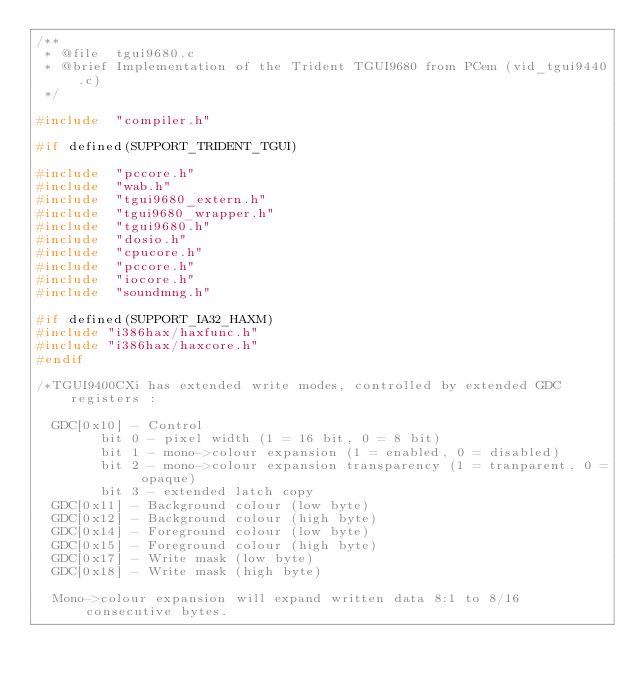Convert code to text. <code><loc_0><loc_0><loc_500><loc_500><_C_>/**
 * @file	tgui9680.c
 * @brief	Implementation of the Trident TGUI9680 from PCem (vid_tgui9440.c)
 */

#include	"compiler.h"

#if defined(SUPPORT_TRIDENT_TGUI)

#include	"pccore.h"
#include	"wab.h"
#include	"tgui9680_extern.h"
#include	"tgui9680_wrapper.h"
#include	"tgui9680.h"
#include	"dosio.h"
#include	"cpucore.h"
#include	"pccore.h"
#include	"iocore.h"
#include	"soundmng.h"

#if defined(SUPPORT_IA32_HAXM)
#include "i386hax/haxfunc.h"
#include "i386hax/haxcore.h"
#endif

/*TGUI9400CXi has extended write modes, controlled by extended GDC registers :
        
  GDC[0x10] - Control
        bit 0 - pixel width (1 = 16 bit, 0 = 8 bit)
        bit 1 - mono->colour expansion (1 = enabled, 0 = disabled)
        bit 2 - mono->colour expansion transparency (1 = tranparent, 0 = opaque)
        bit 3 - extended latch copy
  GDC[0x11] - Background colour (low byte)
  GDC[0x12] - Background colour (high byte)
  GDC[0x14] - Foreground colour (low byte)
  GDC[0x15] - Foreground colour (high byte)
  GDC[0x17] - Write mask (low byte)
  GDC[0x18] - Write mask (high byte)
  
  Mono->colour expansion will expand written data 8:1 to 8/16 consecutive bytes.</code> 